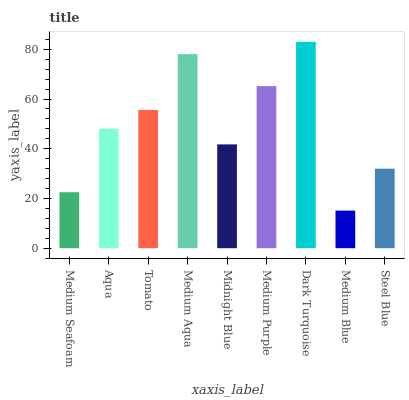Is Medium Blue the minimum?
Answer yes or no. Yes. Is Dark Turquoise the maximum?
Answer yes or no. Yes. Is Aqua the minimum?
Answer yes or no. No. Is Aqua the maximum?
Answer yes or no. No. Is Aqua greater than Medium Seafoam?
Answer yes or no. Yes. Is Medium Seafoam less than Aqua?
Answer yes or no. Yes. Is Medium Seafoam greater than Aqua?
Answer yes or no. No. Is Aqua less than Medium Seafoam?
Answer yes or no. No. Is Aqua the high median?
Answer yes or no. Yes. Is Aqua the low median?
Answer yes or no. Yes. Is Medium Aqua the high median?
Answer yes or no. No. Is Steel Blue the low median?
Answer yes or no. No. 